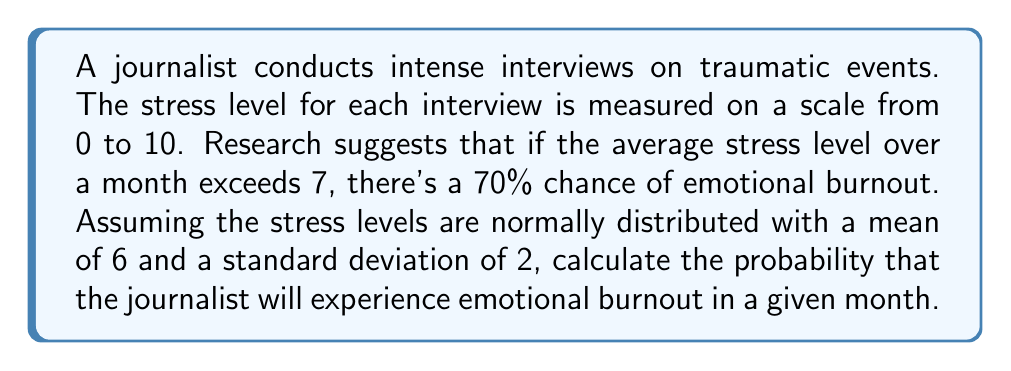Solve this math problem. Let's approach this step-by-step:

1) Let X be the random variable representing the average stress level over a month.

2) We're given that X follows a normal distribution with:
   $\mu = 6$ (mean)
   $\sigma = 2$ (standard deviation)

3) We need to find P(X > 7), as emotional burnout occurs when the average stress level exceeds 7.

4) For a normal distribution, we can standardize the variable using the z-score formula:

   $z = \frac{x - \mu}{\sigma}$

5) Calculating the z-score for X = 7:

   $z = \frac{7 - 6}{2} = 0.5$

6) Now, we need to find P(Z > 0.5) where Z is the standard normal variable.

7) Using a standard normal table or calculator, we can find that:
   P(Z > 0.5) ≈ 0.3085

8) This means the probability of the average stress level exceeding 7 is about 0.3085.

9) However, the question asks for the probability of emotional burnout. Given that the stress level exceeds 7, there's a 70% chance of burnout.

10) Therefore, we multiply our result by 0.70:

    0.3085 * 0.70 ≈ 0.2160

Thus, the probability of the journalist experiencing emotional burnout in a given month is approximately 0.2160 or 21.60%.
Answer: 0.2160 or 21.60% 